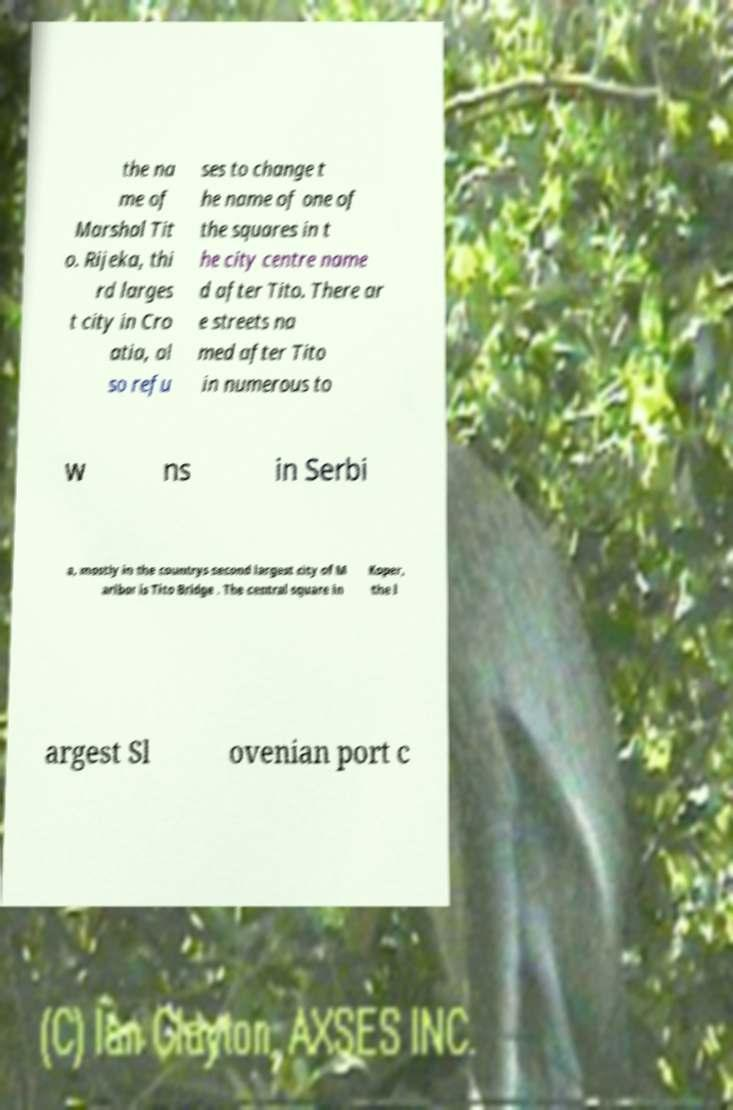Could you extract and type out the text from this image? the na me of Marshal Tit o. Rijeka, thi rd larges t city in Cro atia, al so refu ses to change t he name of one of the squares in t he city centre name d after Tito. There ar e streets na med after Tito in numerous to w ns in Serbi a, mostly in the countrys second largest city of M aribor is Tito Bridge . The central square in Koper, the l argest Sl ovenian port c 